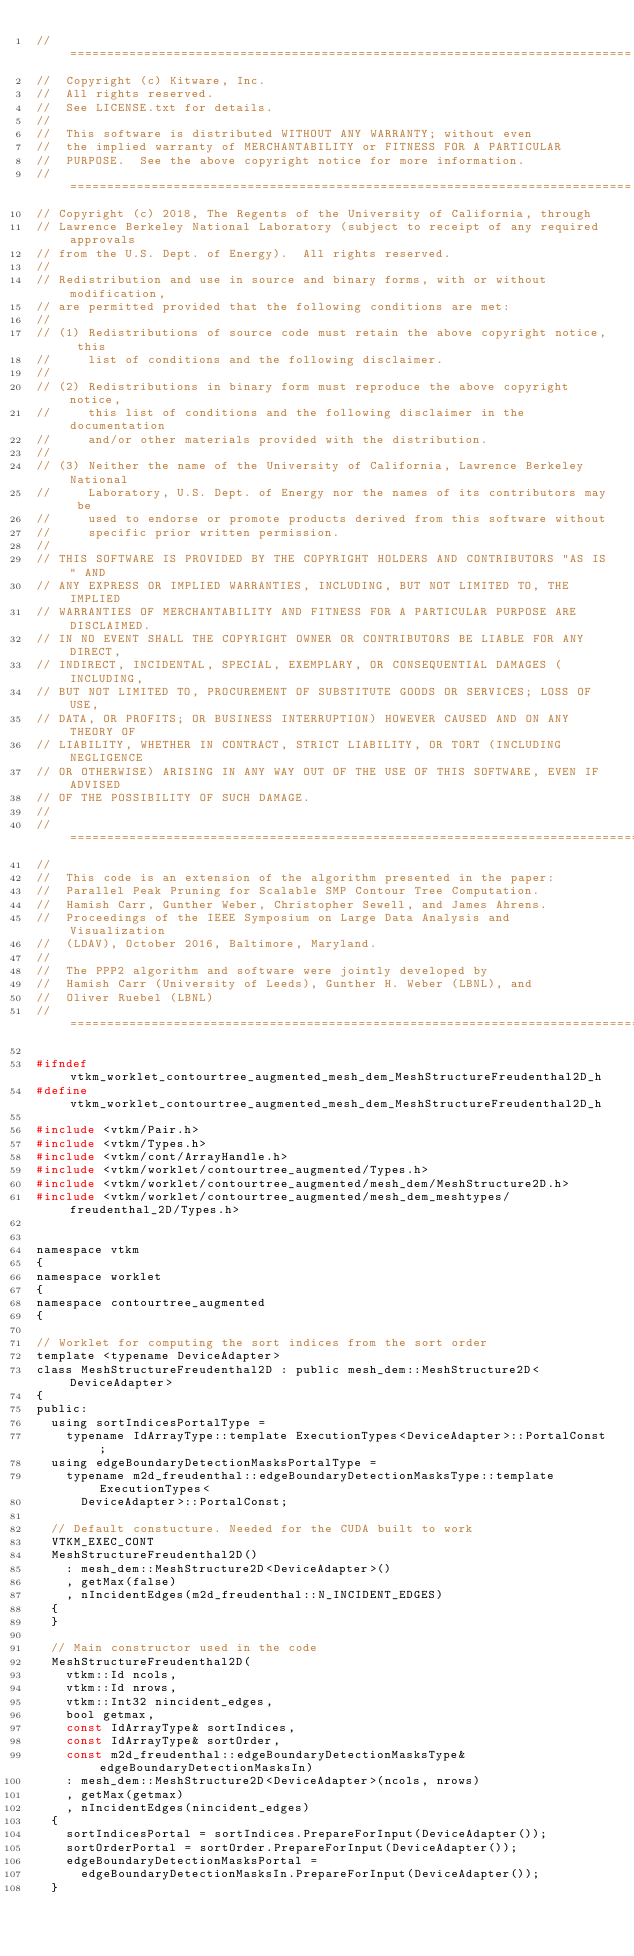<code> <loc_0><loc_0><loc_500><loc_500><_C_>//============================================================================
//  Copyright (c) Kitware, Inc.
//  All rights reserved.
//  See LICENSE.txt for details.
//
//  This software is distributed WITHOUT ANY WARRANTY; without even
//  the implied warranty of MERCHANTABILITY or FITNESS FOR A PARTICULAR
//  PURPOSE.  See the above copyright notice for more information.
//============================================================================
// Copyright (c) 2018, The Regents of the University of California, through
// Lawrence Berkeley National Laboratory (subject to receipt of any required approvals
// from the U.S. Dept. of Energy).  All rights reserved.
//
// Redistribution and use in source and binary forms, with or without modification,
// are permitted provided that the following conditions are met:
//
// (1) Redistributions of source code must retain the above copyright notice, this
//     list of conditions and the following disclaimer.
//
// (2) Redistributions in binary form must reproduce the above copyright notice,
//     this list of conditions and the following disclaimer in the documentation
//     and/or other materials provided with the distribution.
//
// (3) Neither the name of the University of California, Lawrence Berkeley National
//     Laboratory, U.S. Dept. of Energy nor the names of its contributors may be
//     used to endorse or promote products derived from this software without
//     specific prior written permission.
//
// THIS SOFTWARE IS PROVIDED BY THE COPYRIGHT HOLDERS AND CONTRIBUTORS "AS IS" AND
// ANY EXPRESS OR IMPLIED WARRANTIES, INCLUDING, BUT NOT LIMITED TO, THE IMPLIED
// WARRANTIES OF MERCHANTABILITY AND FITNESS FOR A PARTICULAR PURPOSE ARE DISCLAIMED.
// IN NO EVENT SHALL THE COPYRIGHT OWNER OR CONTRIBUTORS BE LIABLE FOR ANY DIRECT,
// INDIRECT, INCIDENTAL, SPECIAL, EXEMPLARY, OR CONSEQUENTIAL DAMAGES (INCLUDING,
// BUT NOT LIMITED TO, PROCUREMENT OF SUBSTITUTE GOODS OR SERVICES; LOSS OF USE,
// DATA, OR PROFITS; OR BUSINESS INTERRUPTION) HOWEVER CAUSED AND ON ANY THEORY OF
// LIABILITY, WHETHER IN CONTRACT, STRICT LIABILITY, OR TORT (INCLUDING NEGLIGENCE
// OR OTHERWISE) ARISING IN ANY WAY OUT OF THE USE OF THIS SOFTWARE, EVEN IF ADVISED
// OF THE POSSIBILITY OF SUCH DAMAGE.
//
//=============================================================================
//
//  This code is an extension of the algorithm presented in the paper:
//  Parallel Peak Pruning for Scalable SMP Contour Tree Computation.
//  Hamish Carr, Gunther Weber, Christopher Sewell, and James Ahrens.
//  Proceedings of the IEEE Symposium on Large Data Analysis and Visualization
//  (LDAV), October 2016, Baltimore, Maryland.
//
//  The PPP2 algorithm and software were jointly developed by
//  Hamish Carr (University of Leeds), Gunther H. Weber (LBNL), and
//  Oliver Ruebel (LBNL)
//==============================================================================

#ifndef vtkm_worklet_contourtree_augmented_mesh_dem_MeshStructureFreudenthal2D_h
#define vtkm_worklet_contourtree_augmented_mesh_dem_MeshStructureFreudenthal2D_h

#include <vtkm/Pair.h>
#include <vtkm/Types.h>
#include <vtkm/cont/ArrayHandle.h>
#include <vtkm/worklet/contourtree_augmented/Types.h>
#include <vtkm/worklet/contourtree_augmented/mesh_dem/MeshStructure2D.h>
#include <vtkm/worklet/contourtree_augmented/mesh_dem_meshtypes/freudenthal_2D/Types.h>


namespace vtkm
{
namespace worklet
{
namespace contourtree_augmented
{

// Worklet for computing the sort indices from the sort order
template <typename DeviceAdapter>
class MeshStructureFreudenthal2D : public mesh_dem::MeshStructure2D<DeviceAdapter>
{
public:
  using sortIndicesPortalType =
    typename IdArrayType::template ExecutionTypes<DeviceAdapter>::PortalConst;
  using edgeBoundaryDetectionMasksPortalType =
    typename m2d_freudenthal::edgeBoundaryDetectionMasksType::template ExecutionTypes<
      DeviceAdapter>::PortalConst;

  // Default constucture. Needed for the CUDA built to work
  VTKM_EXEC_CONT
  MeshStructureFreudenthal2D()
    : mesh_dem::MeshStructure2D<DeviceAdapter>()
    , getMax(false)
    , nIncidentEdges(m2d_freudenthal::N_INCIDENT_EDGES)
  {
  }

  // Main constructor used in the code
  MeshStructureFreudenthal2D(
    vtkm::Id ncols,
    vtkm::Id nrows,
    vtkm::Int32 nincident_edges,
    bool getmax,
    const IdArrayType& sortIndices,
    const IdArrayType& sortOrder,
    const m2d_freudenthal::edgeBoundaryDetectionMasksType& edgeBoundaryDetectionMasksIn)
    : mesh_dem::MeshStructure2D<DeviceAdapter>(ncols, nrows)
    , getMax(getmax)
    , nIncidentEdges(nincident_edges)
  {
    sortIndicesPortal = sortIndices.PrepareForInput(DeviceAdapter());
    sortOrderPortal = sortOrder.PrepareForInput(DeviceAdapter());
    edgeBoundaryDetectionMasksPortal =
      edgeBoundaryDetectionMasksIn.PrepareForInput(DeviceAdapter());
  }
</code> 